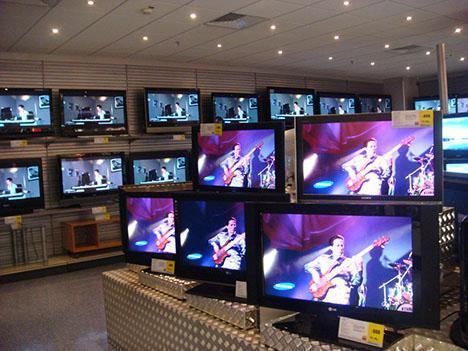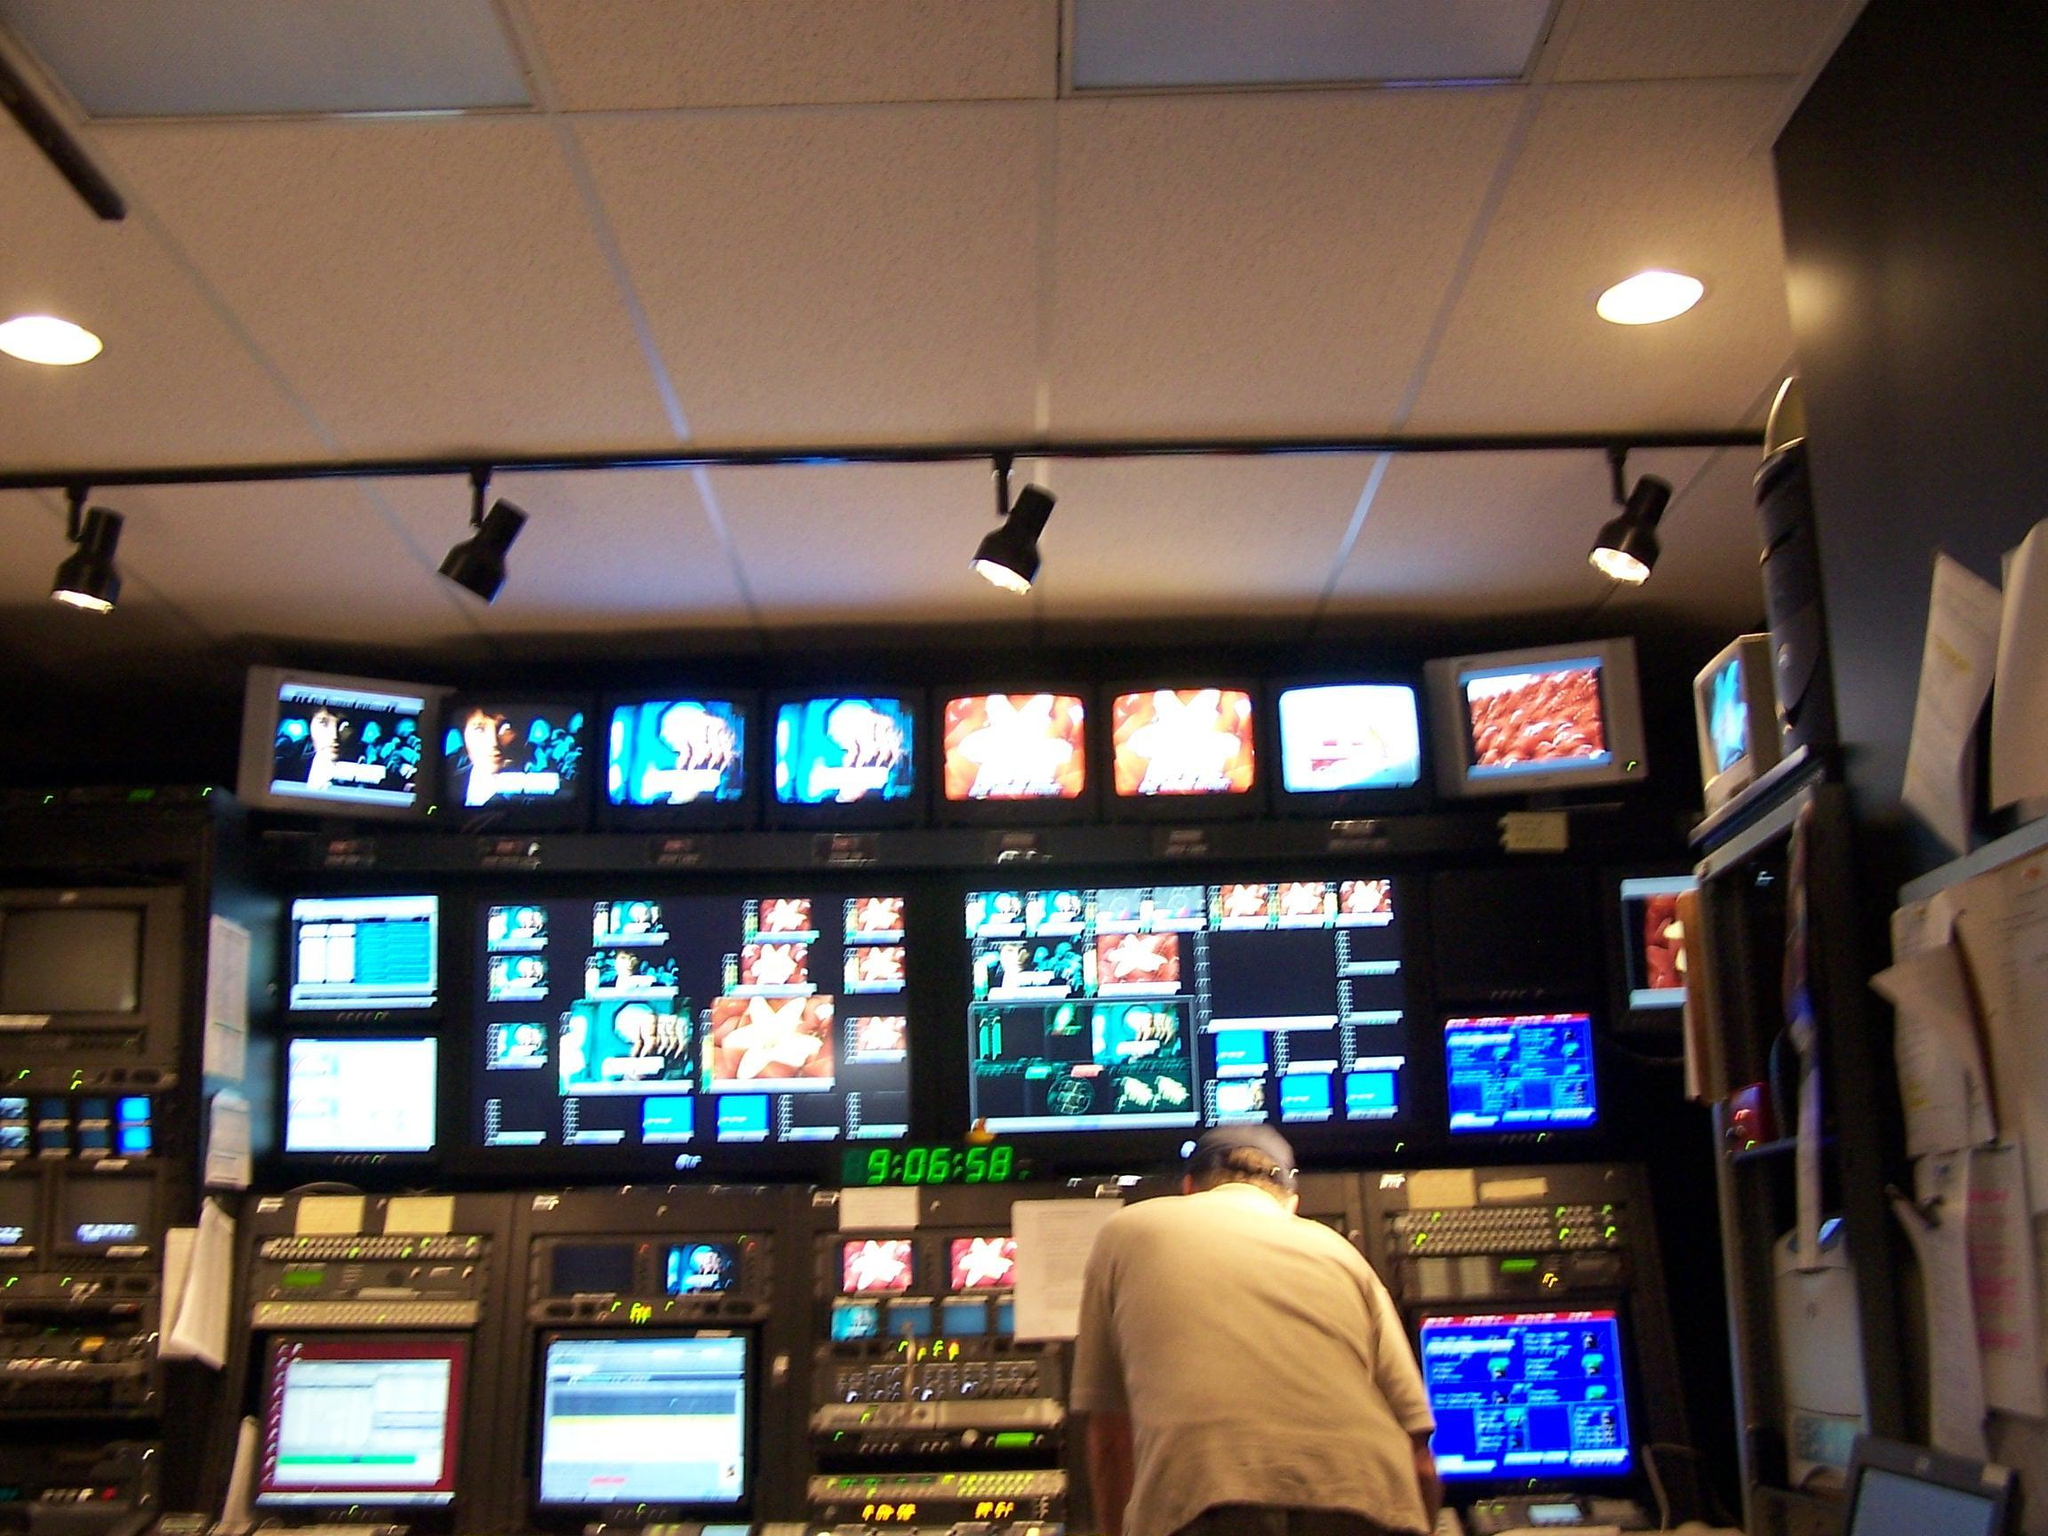The first image is the image on the left, the second image is the image on the right. For the images shown, is this caption "There are spotlights hanging from the ceiling in one of the images." true? Answer yes or no. Yes. The first image is the image on the left, the second image is the image on the right. Evaluate the accuracy of this statement regarding the images: "In one image, the screens are in a store setting.". Is it true? Answer yes or no. Yes. 